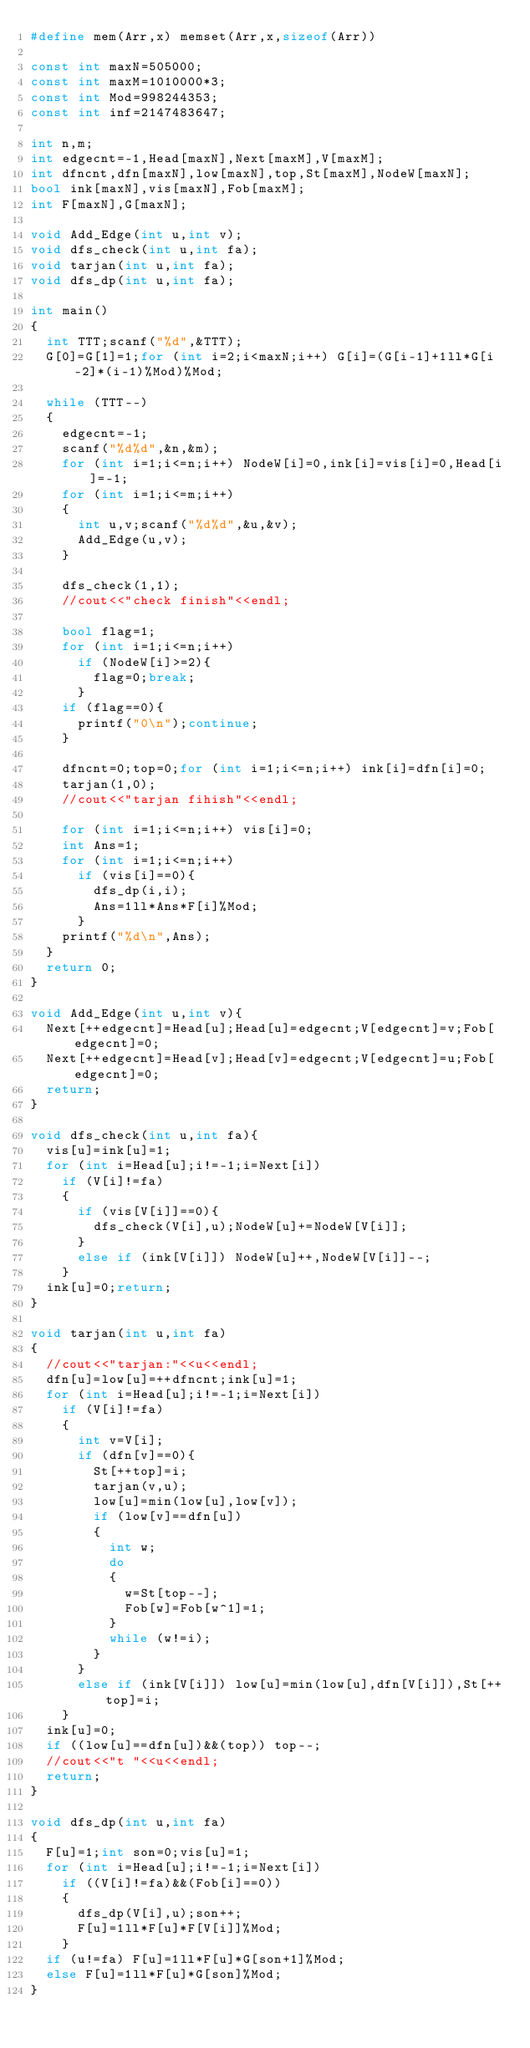<code> <loc_0><loc_0><loc_500><loc_500><_C++_>#define mem(Arr,x) memset(Arr,x,sizeof(Arr))

const int maxN=505000;
const int maxM=1010000*3;
const int Mod=998244353;
const int inf=2147483647;

int n,m;
int edgecnt=-1,Head[maxN],Next[maxM],V[maxM];
int dfncnt,dfn[maxN],low[maxN],top,St[maxM],NodeW[maxN];
bool ink[maxN],vis[maxN],Fob[maxM];
int F[maxN],G[maxN];

void Add_Edge(int u,int v);
void dfs_check(int u,int fa);
void tarjan(int u,int fa);
void dfs_dp(int u,int fa);

int main()
{
	int TTT;scanf("%d",&TTT);
	G[0]=G[1]=1;for (int i=2;i<maxN;i++) G[i]=(G[i-1]+1ll*G[i-2]*(i-1)%Mod)%Mod;
	
	while (TTT--)
	{
		edgecnt=-1;
		scanf("%d%d",&n,&m);
		for (int i=1;i<=n;i++) NodeW[i]=0,ink[i]=vis[i]=0,Head[i]=-1;
		for (int i=1;i<=m;i++)
		{
			int u,v;scanf("%d%d",&u,&v);
			Add_Edge(u,v);
		}

		dfs_check(1,1);
		//cout<<"check finish"<<endl;

		bool flag=1;
		for (int i=1;i<=n;i++)
			if (NodeW[i]>=2){
				flag=0;break;
			}
		if (flag==0){
			printf("0\n");continue;
		}

		dfncnt=0;top=0;for (int i=1;i<=n;i++) ink[i]=dfn[i]=0;
		tarjan(1,0);
		//cout<<"tarjan fihish"<<endl;

		for (int i=1;i<=n;i++) vis[i]=0;
		int Ans=1;
		for (int i=1;i<=n;i++)
			if (vis[i]==0){
				dfs_dp(i,i);
				Ans=1ll*Ans*F[i]%Mod;
			}
		printf("%d\n",Ans);
	}
	return 0;
}

void Add_Edge(int u,int v){
	Next[++edgecnt]=Head[u];Head[u]=edgecnt;V[edgecnt]=v;Fob[edgecnt]=0;
	Next[++edgecnt]=Head[v];Head[v]=edgecnt;V[edgecnt]=u;Fob[edgecnt]=0;
	return;
}

void dfs_check(int u,int fa){
	vis[u]=ink[u]=1;
	for (int i=Head[u];i!=-1;i=Next[i])
		if (V[i]!=fa)
		{
			if (vis[V[i]]==0){
				dfs_check(V[i],u);NodeW[u]+=NodeW[V[i]];
			}
			else if (ink[V[i]]) NodeW[u]++,NodeW[V[i]]--;
		}
	ink[u]=0;return;
}

void tarjan(int u,int fa)
{
	//cout<<"tarjan:"<<u<<endl;
	dfn[u]=low[u]=++dfncnt;ink[u]=1;
	for (int i=Head[u];i!=-1;i=Next[i])
		if (V[i]!=fa)
		{
			int v=V[i];
			if (dfn[v]==0){
				St[++top]=i;
				tarjan(v,u);
				low[u]=min(low[u],low[v]);
				if (low[v]==dfn[u])
				{
					int w;
					do
					{
						w=St[top--];
						Fob[w]=Fob[w^1]=1;
					}
					while (w!=i);
				}
			}
			else if (ink[V[i]]) low[u]=min(low[u],dfn[V[i]]),St[++top]=i;
		}
	ink[u]=0;
	if ((low[u]==dfn[u])&&(top)) top--;
	//cout<<"t "<<u<<endl;
	return;
}

void dfs_dp(int u,int fa)
{
	F[u]=1;int son=0;vis[u]=1;
	for (int i=Head[u];i!=-1;i=Next[i])
		if ((V[i]!=fa)&&(Fob[i]==0))
		{
			dfs_dp(V[i],u);son++;
			F[u]=1ll*F[u]*F[V[i]]%Mod;
		}
	if (u!=fa) F[u]=1ll*F[u]*G[son+1]%Mod;
	else F[u]=1ll*F[u]*G[son]%Mod;
}

</code> 